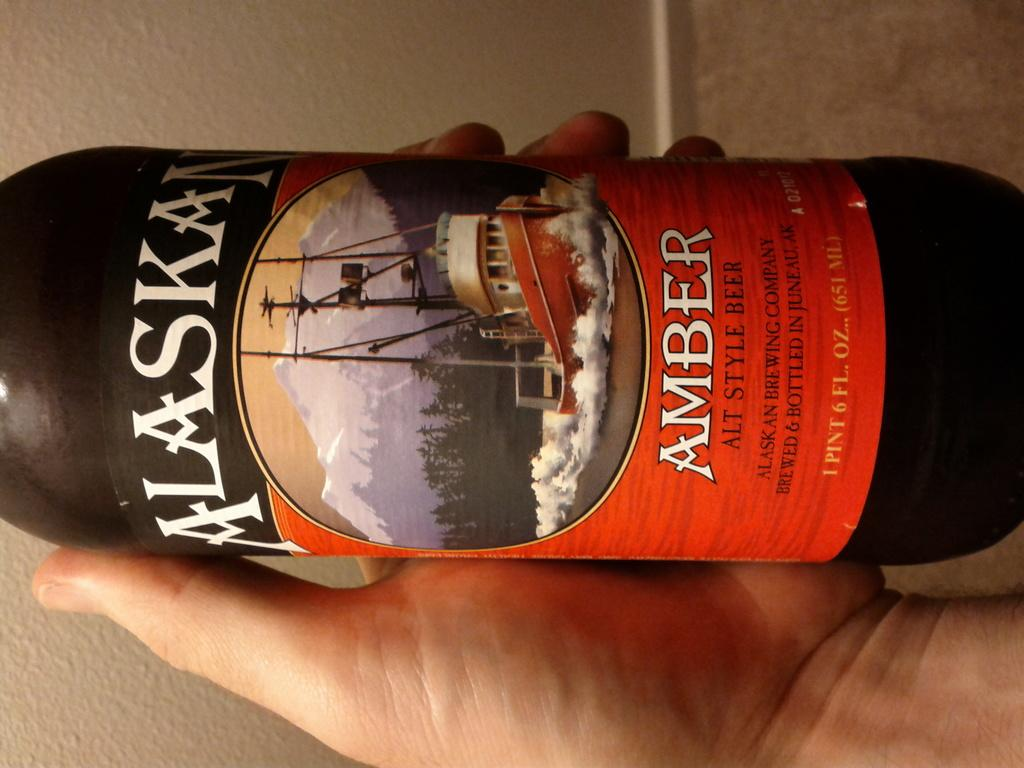What is present in the image? There is a person in the image. What is the person holding? The person is holding a bottle. What type of furniture can be seen in the image? There is no furniture present in the image; it only features a person holding a bottle. What scent is associated with the person in the image? There is no information about the scent of the person or the bottle in the image. 